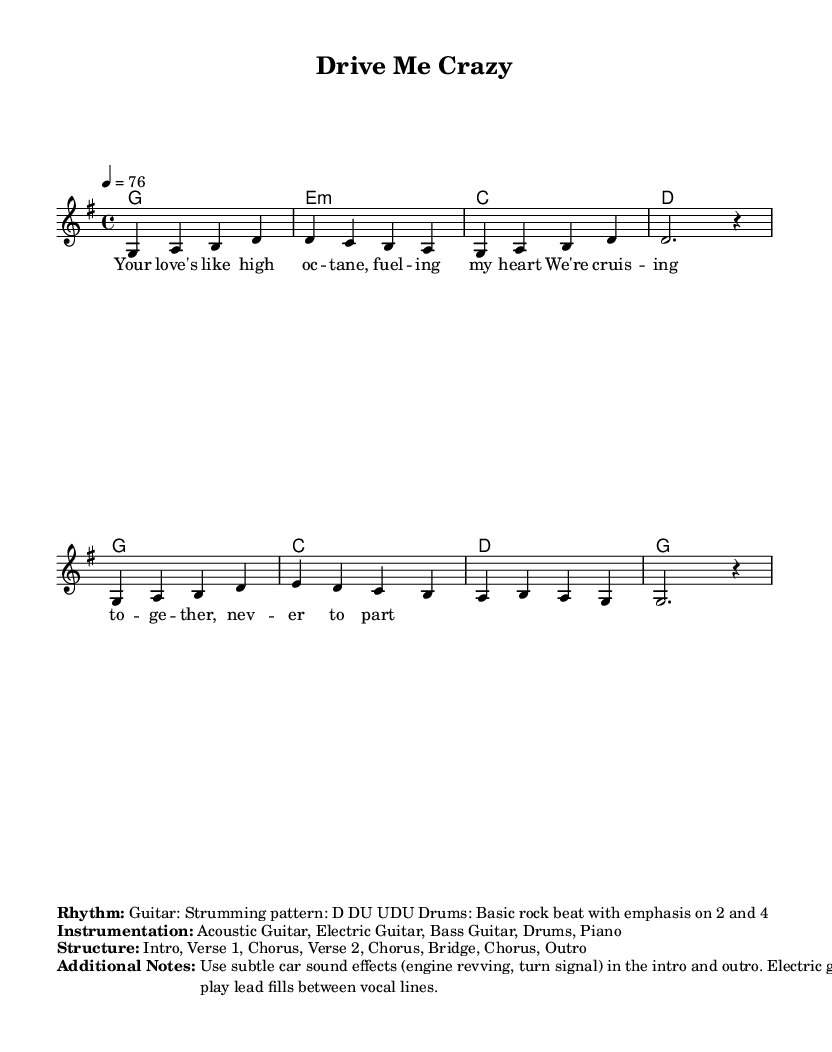What is the key signature of this music? The key signature is G major, which has one sharp (F#). This can be determined by looking at the key signature indicated at the beginning of the sheet music.
Answer: G major What is the time signature of this piece? The time signature is 4/4, which indicates that there are four beats in each measure and the quarter note gets one beat. This is shown at the beginning of the sheet music.
Answer: 4/4 What is the tempo marking for this music? The tempo marking is 76 beats per minute, as indicated by "4 = 76," which informs the performer of the speed at which to play the piece.
Answer: 76 How many verses are indicated in the structure? The structure notes two verses: "Verse 1" and "Verse 2," showing that the song has a repeat of the verse format. This is specified in the structured section of the sheet music.
Answer: 2 Which instruments are included in the instrumentation? The instrumentation includes Acoustic Guitar, Electric Guitar, Bass Guitar, Drums, and Piano. This is listed under the "Instrumentation" section of the sheet music.
Answer: Acoustic Guitar, Electric Guitar, Bass Guitar, Drums, Piano What metaphor is used for love in the lyrics? The metaphor used for love is "high octane," which likens love to a powerful fuel for the heart, illustrating an intense and passionate relationship. This is found in the verse lyrics.
Answer: high octane In which part of the song do car sound effects appear? Car sound effects are noted to be used in the intro and outro of the song, enhancing the automotive theme of the piece. This is mentioned in the "Additional Notes" section.
Answer: intro and outro 